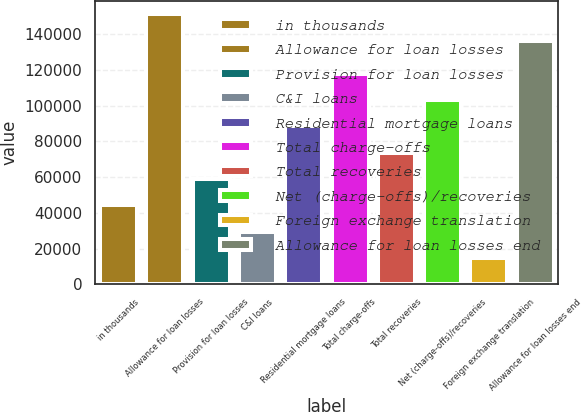<chart> <loc_0><loc_0><loc_500><loc_500><bar_chart><fcel>in thousands<fcel>Allowance for loan losses<fcel>Provision for loan losses<fcel>C&I loans<fcel>Residential mortgage loans<fcel>Total charge-offs<fcel>Total recoveries<fcel>Net (charge-offs)/recoveries<fcel>Foreign exchange translation<fcel>Allowance for loan losses end<nl><fcel>44263.4<fcel>151255<fcel>59017.3<fcel>29509.4<fcel>88525.2<fcel>118033<fcel>73771.3<fcel>103279<fcel>14755.5<fcel>136501<nl></chart> 